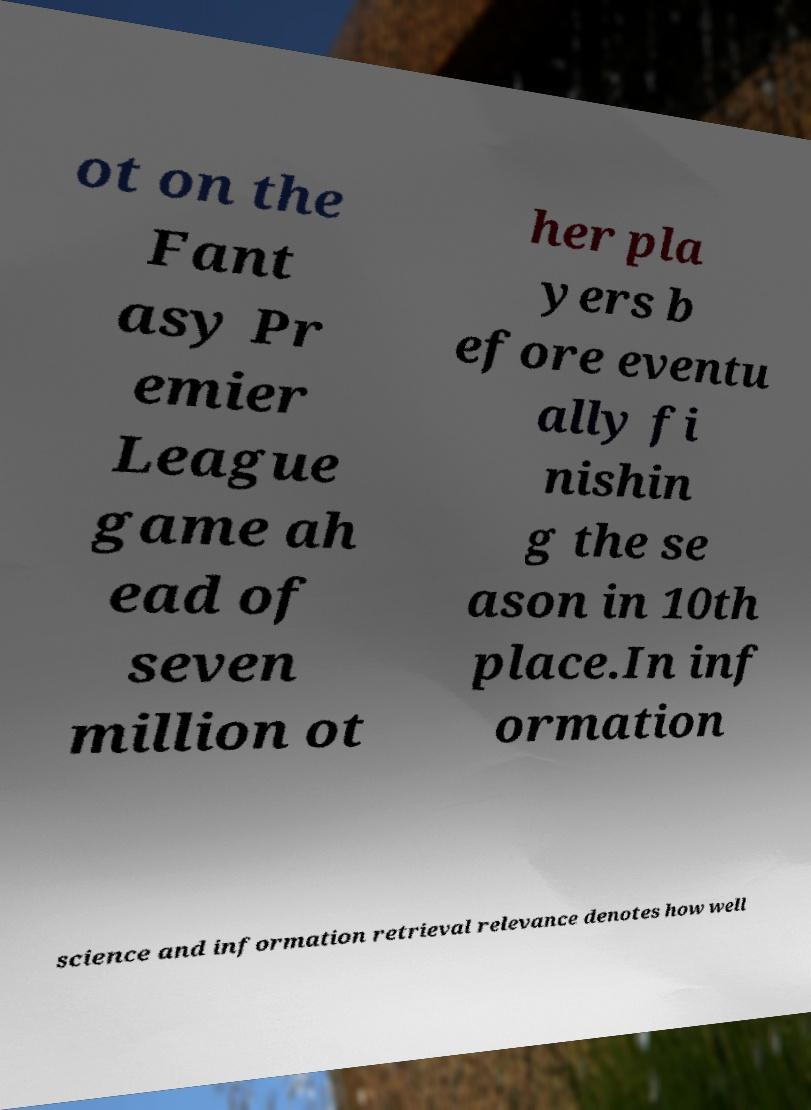Could you assist in decoding the text presented in this image and type it out clearly? ot on the Fant asy Pr emier League game ah ead of seven million ot her pla yers b efore eventu ally fi nishin g the se ason in 10th place.In inf ormation science and information retrieval relevance denotes how well 